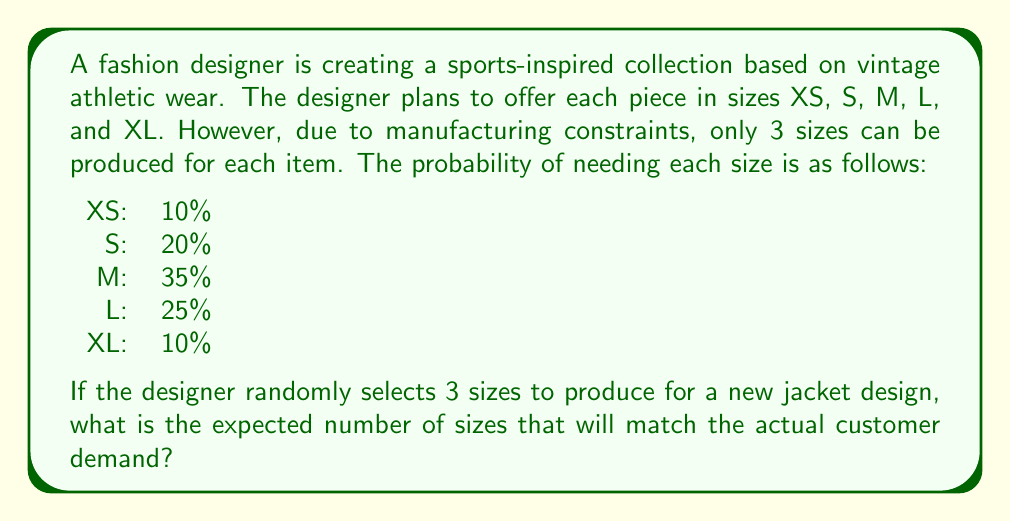Give your solution to this math problem. To solve this problem, we need to calculate the expected value of the number of sizes that will match customer demand. Let's approach this step-by-step:

1) First, we need to calculate the probability of selecting each possible combination of 3 sizes out of 5. There are $\binom{5}{3} = 10$ possible combinations.

2) For each combination, we need to sum the probabilities of the selected sizes to get the probability of matching customer demand.

3) Let's list all combinations and their corresponding probabilities:

   XS, S, M: 0.10 + 0.20 + 0.35 = 0.65
   XS, S, L: 0.10 + 0.20 + 0.25 = 0.55
   XS, S, XL: 0.10 + 0.20 + 0.10 = 0.40
   XS, M, L: 0.10 + 0.35 + 0.25 = 0.70
   XS, M, XL: 0.10 + 0.35 + 0.10 = 0.55
   XS, L, XL: 0.10 + 0.25 + 0.10 = 0.45
   S, M, L: 0.20 + 0.35 + 0.25 = 0.80
   S, M, XL: 0.20 + 0.35 + 0.10 = 0.65
   S, L, XL: 0.20 + 0.25 + 0.10 = 0.55
   M, L, XL: 0.35 + 0.25 + 0.10 = 0.70

4) The probability of each combination being selected is $\frac{1}{10}$ (assuming random selection).

5) Now, we can calculate the expected value:

   $$E = \frac{1}{10}(0.65 + 0.55 + 0.40 + 0.70 + 0.55 + 0.45 + 0.80 + 0.65 + 0.55 + 0.70)$$

6) Simplifying:

   $$E = \frac{1}{10}(6.00) = 0.60$$

Therefore, the expected number of sizes that will match the actual customer demand is 0.60 or 60% of the 3 sizes produced.
Answer: 0.60 